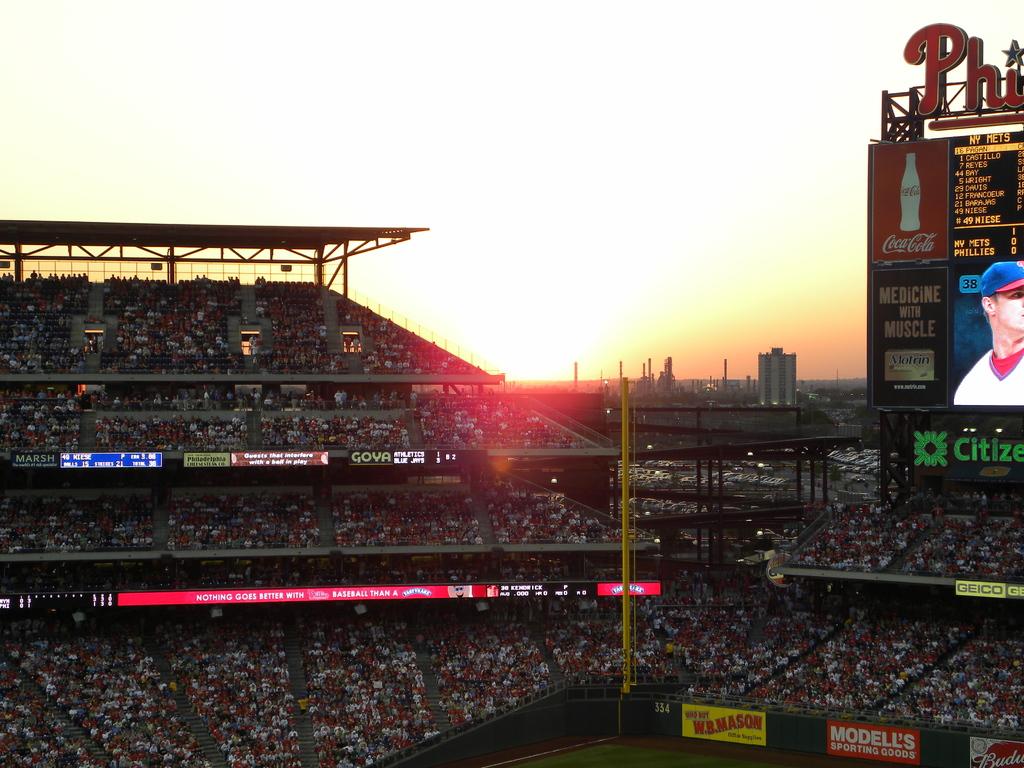What soda advertisement is on the billboard?
Give a very brief answer. Coca cola. What team are the phillies playing against?
Your answer should be very brief. Mets. 